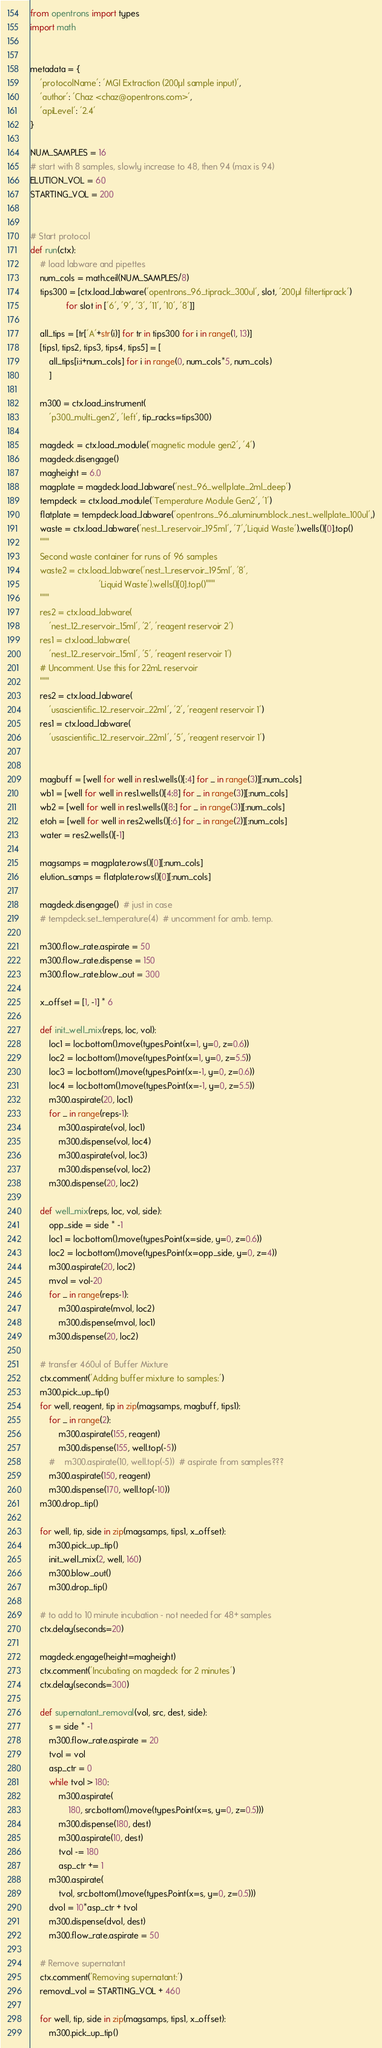<code> <loc_0><loc_0><loc_500><loc_500><_Python_>from opentrons import types
import math


metadata = {
    'protocolName': 'MGI Extraction (200µl sample input)',
    'author': 'Chaz <chaz@opentrons.com>',
    'apiLevel': '2.4'
}

NUM_SAMPLES = 16
# start with 8 samples, slowly increase to 48, then 94 (max is 94)
ELUTION_VOL = 60
STARTING_VOL = 200


# Start protocol
def run(ctx):
    # load labware and pipettes
    num_cols = math.ceil(NUM_SAMPLES/8)
    tips300 = [ctx.load_labware('opentrons_96_tiprack_300ul', slot, '200µl filtertiprack')
               for slot in ['6', '9', '3', '11', '10', '8']]

    all_tips = [tr['A'+str(i)] for tr in tips300 for i in range(1, 13)]
    [tips1, tips2, tips3, tips4, tips5] = [
        all_tips[i:i+num_cols] for i in range(0, num_cols*5, num_cols)
        ]

    m300 = ctx.load_instrument(
        'p300_multi_gen2', 'left', tip_racks=tips300)

    magdeck = ctx.load_module('magnetic module gen2', '4')
    magdeck.disengage()
    magheight = 6.0
    magplate = magdeck.load_labware('nest_96_wellplate_2ml_deep')
    tempdeck = ctx.load_module('Temperature Module Gen2', '1')
    flatplate = tempdeck.load_labware('opentrons_96_aluminumblock_nest_wellplate_100ul',)
    waste = ctx.load_labware('nest_1_reservoir_195ml', '7','Liquid Waste').wells()[0].top()
    """
    Second waste container for runs of 96 samples
    waste2 = ctx.load_labware('nest_1_reservoir_195ml', '8',
                             'Liquid Waste').wells()[0].top()"""
    """
    res2 = ctx.load_labware(
        'nest_12_reservoir_15ml', '2', 'reagent reservoir 2')
    res1 = ctx.load_labware(
        'nest_12_reservoir_15ml', '5', 'reagent reservoir 1')
    # Uncomment. Use this for 22mL reservoir
    """
    res2 = ctx.load_labware(
        'usascientific_12_reservoir_22ml', '2', 'reagent reservoir 1')
    res1 = ctx.load_labware(
        'usascientific_12_reservoir_22ml', '5', 'reagent reservoir 1')


    magbuff = [well for well in res1.wells()[:4] for _ in range(3)][:num_cols]
    wb1 = [well for well in res1.wells()[4:8] for _ in range(3)][:num_cols]
    wb2 = [well for well in res1.wells()[8:] for _ in range(3)][:num_cols]
    etoh = [well for well in res2.wells()[:6] for _ in range(2)][:num_cols]
    water = res2.wells()[-1]

    magsamps = magplate.rows()[0][:num_cols]
    elution_samps = flatplate.rows()[0][:num_cols]

    magdeck.disengage()  # just in case
    # tempdeck.set_temperature(4)  # uncomment for amb. temp.

    m300.flow_rate.aspirate = 50
    m300.flow_rate.dispense = 150
    m300.flow_rate.blow_out = 300

    x_offset = [1, -1] * 6

    def init_well_mix(reps, loc, vol):
        loc1 = loc.bottom().move(types.Point(x=1, y=0, z=0.6))
        loc2 = loc.bottom().move(types.Point(x=1, y=0, z=5.5))
        loc3 = loc.bottom().move(types.Point(x=-1, y=0, z=0.6))
        loc4 = loc.bottom().move(types.Point(x=-1, y=0, z=5.5))
        m300.aspirate(20, loc1)
        for _ in range(reps-1):
            m300.aspirate(vol, loc1)
            m300.dispense(vol, loc4)
            m300.aspirate(vol, loc3)
            m300.dispense(vol, loc2)
        m300.dispense(20, loc2)

    def well_mix(reps, loc, vol, side):
        opp_side = side * -1
        loc1 = loc.bottom().move(types.Point(x=side, y=0, z=0.6))
        loc2 = loc.bottom().move(types.Point(x=opp_side, y=0, z=4))
        m300.aspirate(20, loc2)
        mvol = vol-20
        for _ in range(reps-1):
            m300.aspirate(mvol, loc2)
            m300.dispense(mvol, loc1)
        m300.dispense(20, loc2)

    # transfer 460ul of Buffer Mixture
    ctx.comment('Adding buffer mixture to samples:')
    m300.pick_up_tip()
    for well, reagent, tip in zip(magsamps, magbuff, tips1):
        for _ in range(2):
            m300.aspirate(155, reagent)
            m300.dispense(155, well.top(-5))
        #    m300.aspirate(10, well.top(-5))  # aspirate from samples???
        m300.aspirate(150, reagent)
        m300.dispense(170, well.top(-10))
    m300.drop_tip()
    
    for well, tip, side in zip(magsamps, tips1, x_offset):
        m300.pick_up_tip()
        init_well_mix(2, well, 160)
        m300.blow_out()
        m300.drop_tip()
    
    # to add to 10 minute incubation - not needed for 48+ samples
    ctx.delay(seconds=20)

    magdeck.engage(height=magheight)
    ctx.comment('Incubating on magdeck for 2 minutes')
    ctx.delay(seconds=300)

    def supernatant_removal(vol, src, dest, side):
        s = side * -1
        m300.flow_rate.aspirate = 20
        tvol = vol
        asp_ctr = 0
        while tvol > 180:
            m300.aspirate(
                180, src.bottom().move(types.Point(x=s, y=0, z=0.5)))
            m300.dispense(180, dest)
            m300.aspirate(10, dest)
            tvol -= 180
            asp_ctr += 1
        m300.aspirate(
            tvol, src.bottom().move(types.Point(x=s, y=0, z=0.5)))
        dvol = 10*asp_ctr + tvol
        m300.dispense(dvol, dest)
        m300.flow_rate.aspirate = 50

    # Remove supernatant
    ctx.comment('Removing supernatant:')
    removal_vol = STARTING_VOL + 460

    for well, tip, side in zip(magsamps, tips1, x_offset):
        m300.pick_up_tip()</code> 